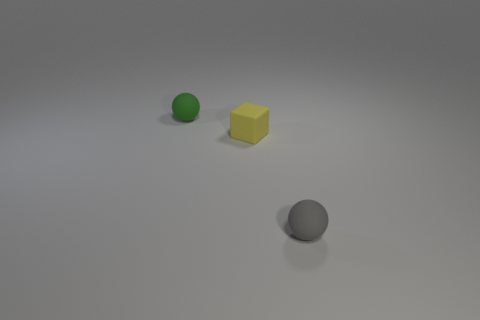What material is the small ball in front of the ball that is behind the object that is to the right of the tiny block?
Provide a succinct answer. Rubber. Do the tiny cube and the small rubber sphere that is in front of the small green rubber thing have the same color?
Provide a succinct answer. No. Are there any other things that are the same shape as the yellow rubber thing?
Give a very brief answer. No. The ball that is behind the matte sphere in front of the green object is what color?
Provide a short and direct response. Green. What number of rubber objects are there?
Your answer should be compact. 3. What number of matte objects are small green things or gray things?
Give a very brief answer. 2. How many matte spheres have the same color as the small matte block?
Give a very brief answer. 0. What material is the small sphere left of the tiny rubber sphere that is in front of the tiny green sphere made of?
Offer a terse response. Rubber. The gray thing has what size?
Give a very brief answer. Small. What number of other yellow rubber cubes have the same size as the yellow block?
Provide a short and direct response. 0. 